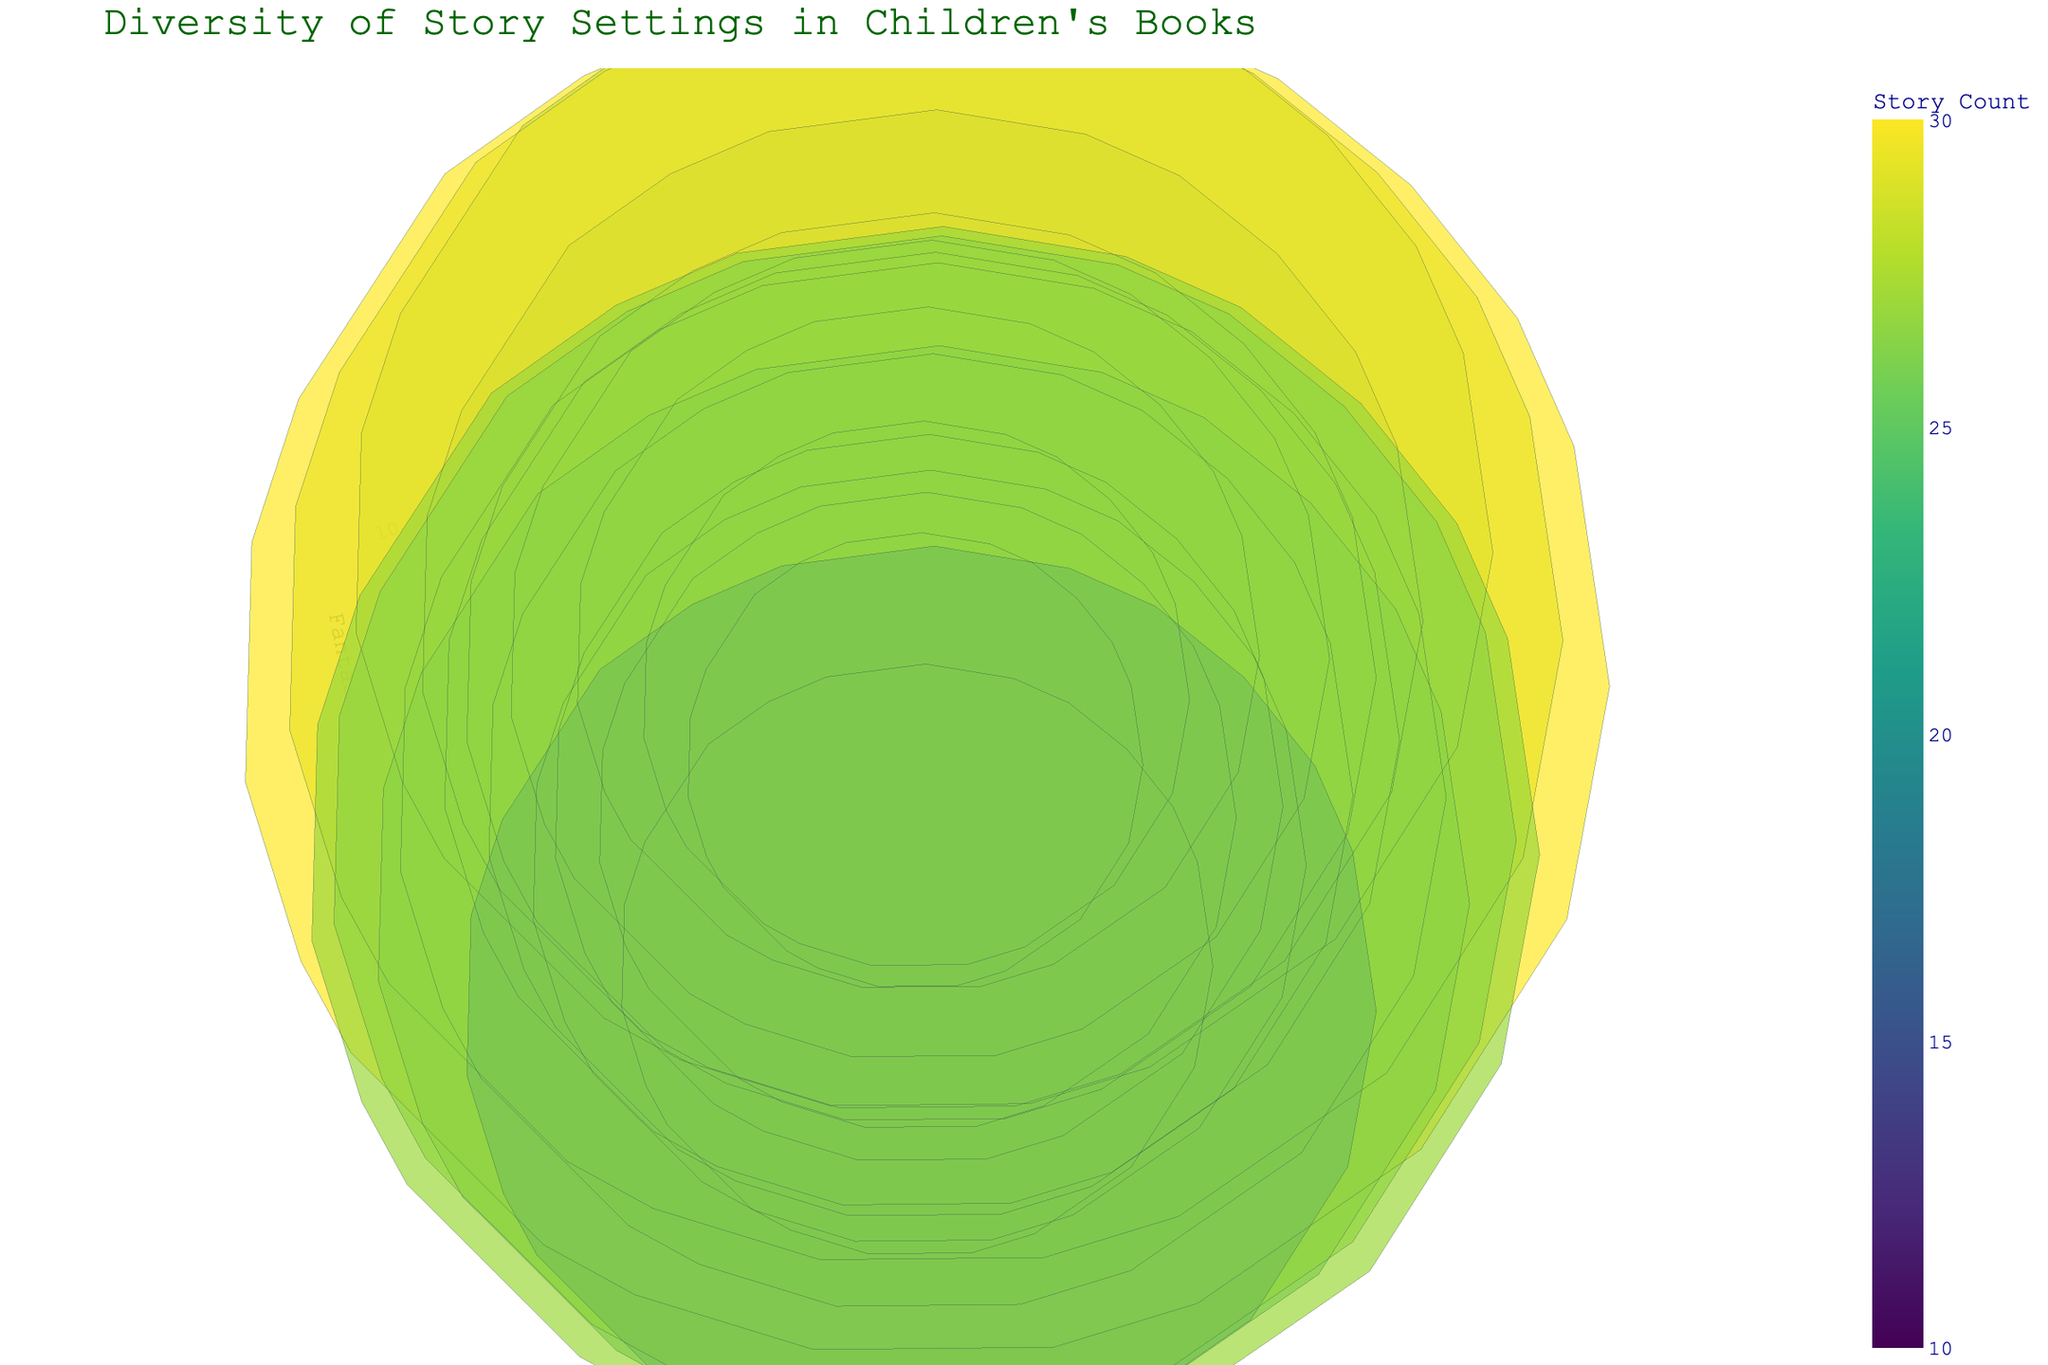What's the title of the figure? The title of the figure is provided in the visual information at the top of the chart.
Answer: Diversity of Story Settings in Children's Books What does the color of the bubbles represent? The color of the bubbles represents the number of stories, with a color scale that varies to show the count distinctly.
Answer: Number of stories Which time period has the most number of stories in an 'Enchanted Forest' location? To find this, locate the 'Enchanted Forest' on the y-axis and then see which time period aligns with the largest bubble in that row.
Answer: Middle Ages What is the total sum of stories set in 'Ancient Egypt' and 'Jurassic Period'? Add the number of stories from Ancient Egypt (20) and Jurassic Period (26).
Answer: 46 Which location has the highest count of fantastical elements? Check each bubble's z-axis (fantastical elements) value and find the highest one, then see the corresponding location.
Answer: Fairyland Comparing 'Future' and 'Steampunk', which has more stories and by how many? Subtract the number of stories in 'Future' (22) from 'Steampunk' (23).
Answer: Steampunk by 1 What is the average number of stories in the 2000s and 1960s? Add the number of stories in 2000s (10) and 1960s (13) and then divide by 2.
Answer: 11.5 Which time period has both the highest number of fantastical elements and the highest number of stories? Identify the time period with the highest values for both z-axis (fantastical elements) and bubble size (story count).
Answer: Fairyland What's the z-axis title in the figure? The z-axis title can be found on the z-axis itself, representing the third dimension.
Answer: Fantastical Elements 